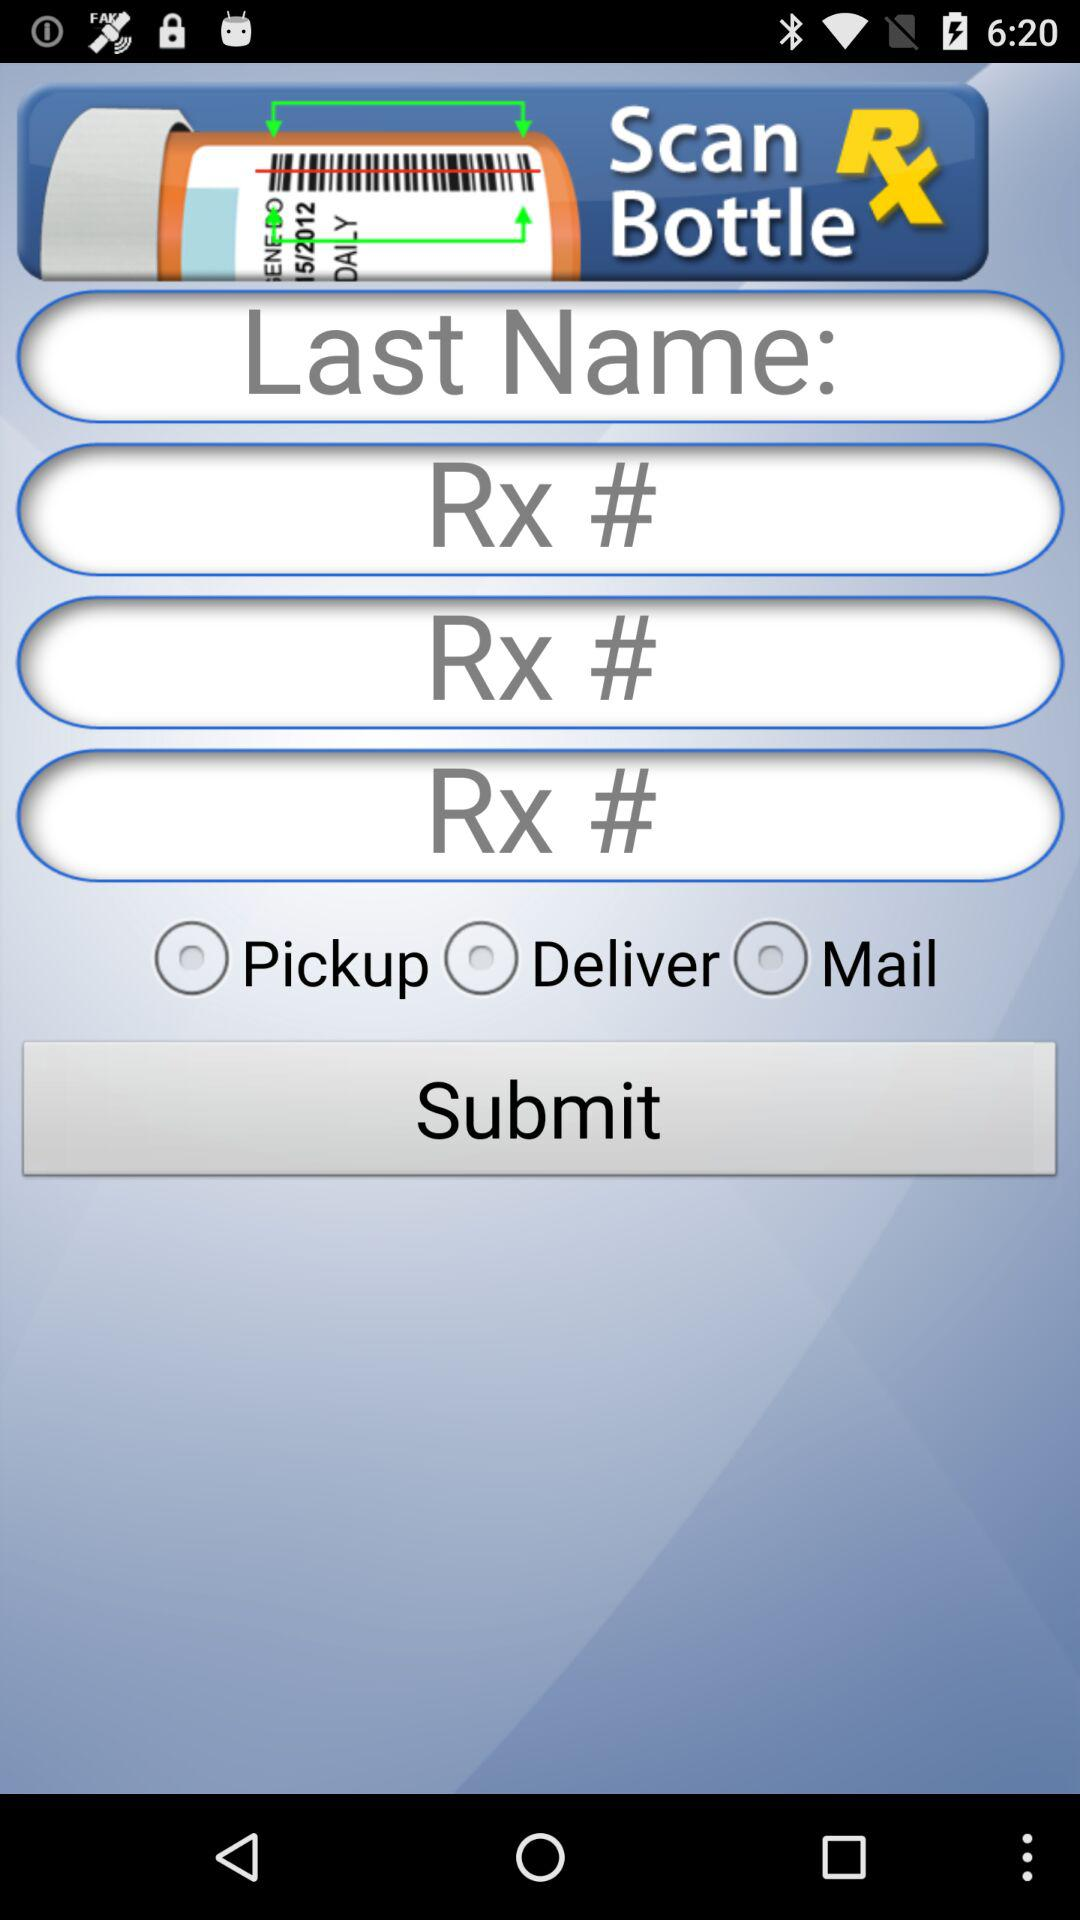What is the name of the application? The name of the application is "Scan RX Bottle". 